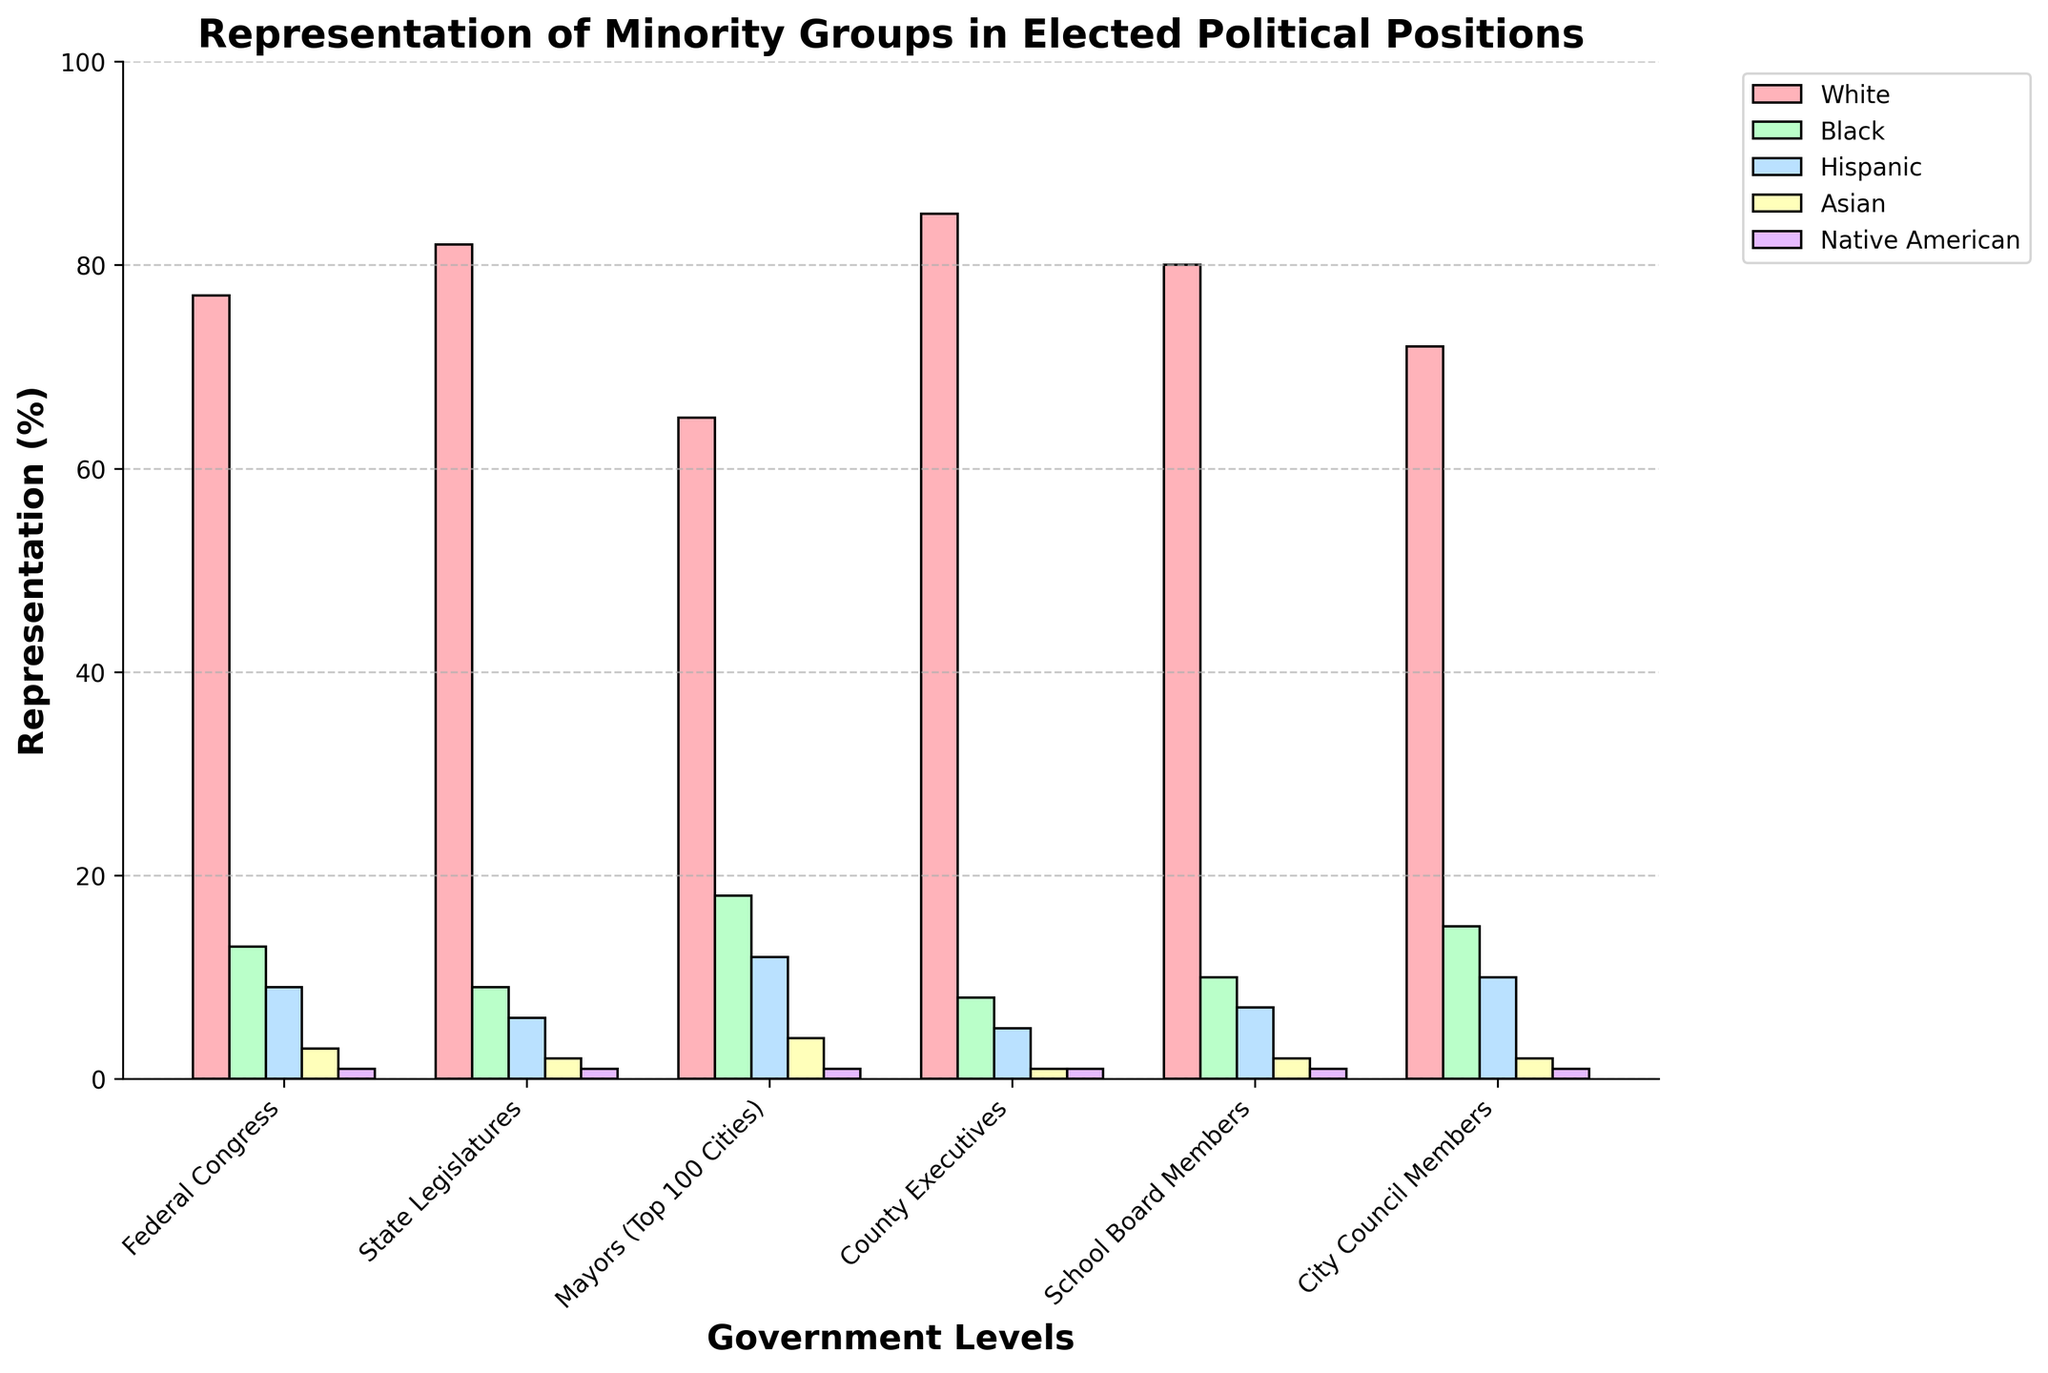What group has the highest representation in Federal Congress? To find this, examine the bars for Federal Congress and identify which is the tallest. The 'White' group has the highest bar at 77%.
Answer: White How does the representation of Asian individuals differ between Mayors of Top 100 Cities and County Executives? Compare the height of the bars for Asian representation between Mayors of Top 100 Cities (4%) and County Executives (1%). The difference is 4% - 1% = 3%.
Answer: 3% Which level of government has the highest representation of Black individuals? Look for the tallest bar for Black individuals across all levels of government. The tallest bar is for Mayors of Top 100 Cities at 18%.
Answer: Mayors of Top 100 Cities What is the average representation of Hispanic individuals across all levels of government? Sum the percentages of Hispanic representation for all levels and then divide by the number of levels. (9 + 6 + 12 + 5 + 7 + 10) / 6 = 8.17%.
Answer: 8.17% Compare the representation of Native American individuals across all levels of government; do any have higher than 1% representation? Review the height of the bars for Native American representation for any that exceed 1%. All levels show exactly 1% representation; none exceed this value.
Answer: No Which level of government has the largest disparity between the highest and lowest represented groups? Find the difference between the highest and lowest represented groups within each level. Federal Congress: 77% - 1% = 76%, State Legislatures: 82% - 1% = 81%, etc. The largest disparity is in State Legislatures at 81%.
Answer: State Legislatures How does the representation of White individuals vary between Mayors of Top 100 Cities and State Legislatures? Subtract the percentage of White representation for Mayors (65%) from State Legislatures (82%). 82% - 65% = 17%.
Answer: 17% Does any government level have equal representation for Black and Hispanic individuals? If yes, which one? Compare the percentages for Black and Hispanic groups across all levels of government. No level has equal representation between these groups.
Answer: No Which group has the least representation in State Legislatures, and what is its percentage? Examine the bars for State Legislatures and identify the shortest, which is Native American at 1%.
Answer: Native American, 1% Sum the representations of Black and Asian individuals in School Board Members. Add the percentages for Black (10%) and Asian (2%) for School Board Members. 10% + 2% = 12%.
Answer: 12% 